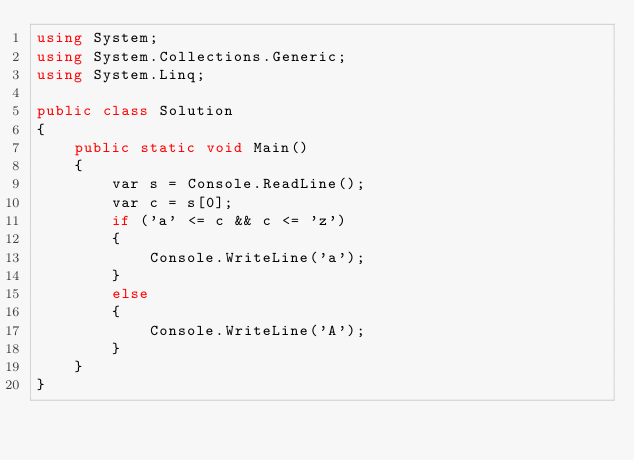Convert code to text. <code><loc_0><loc_0><loc_500><loc_500><_C#_>using System;
using System.Collections.Generic;
using System.Linq;

public class Solution
{
    public static void Main()
    {
        var s = Console.ReadLine();
        var c = s[0];
        if ('a' <= c && c <= 'z')
        {
            Console.WriteLine('a');
        }
        else
        {
            Console.WriteLine('A');
        }
    }
}</code> 